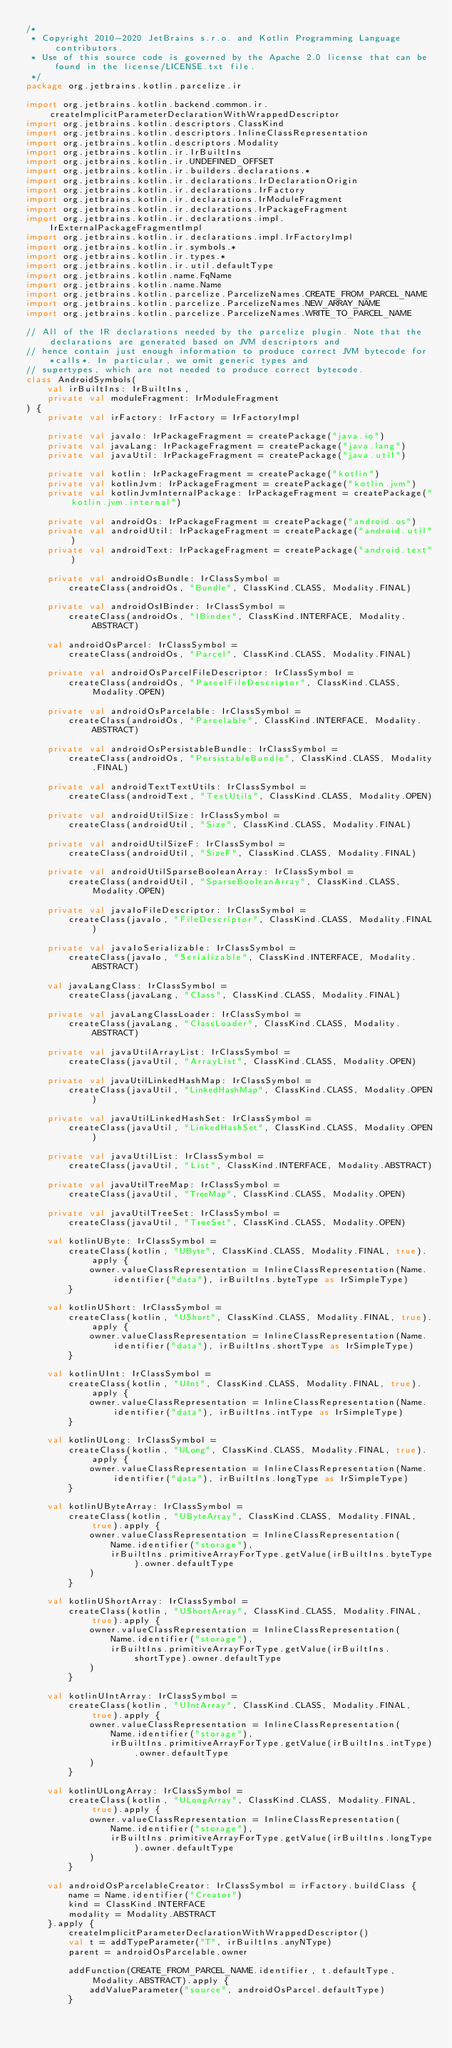<code> <loc_0><loc_0><loc_500><loc_500><_Kotlin_>/*
 * Copyright 2010-2020 JetBrains s.r.o. and Kotlin Programming Language contributors.
 * Use of this source code is governed by the Apache 2.0 license that can be found in the license/LICENSE.txt file.
 */
package org.jetbrains.kotlin.parcelize.ir

import org.jetbrains.kotlin.backend.common.ir.createImplicitParameterDeclarationWithWrappedDescriptor
import org.jetbrains.kotlin.descriptors.ClassKind
import org.jetbrains.kotlin.descriptors.InlineClassRepresentation
import org.jetbrains.kotlin.descriptors.Modality
import org.jetbrains.kotlin.ir.IrBuiltIns
import org.jetbrains.kotlin.ir.UNDEFINED_OFFSET
import org.jetbrains.kotlin.ir.builders.declarations.*
import org.jetbrains.kotlin.ir.declarations.IrDeclarationOrigin
import org.jetbrains.kotlin.ir.declarations.IrFactory
import org.jetbrains.kotlin.ir.declarations.IrModuleFragment
import org.jetbrains.kotlin.ir.declarations.IrPackageFragment
import org.jetbrains.kotlin.ir.declarations.impl.IrExternalPackageFragmentImpl
import org.jetbrains.kotlin.ir.declarations.impl.IrFactoryImpl
import org.jetbrains.kotlin.ir.symbols.*
import org.jetbrains.kotlin.ir.types.*
import org.jetbrains.kotlin.ir.util.defaultType
import org.jetbrains.kotlin.name.FqName
import org.jetbrains.kotlin.name.Name
import org.jetbrains.kotlin.parcelize.ParcelizeNames.CREATE_FROM_PARCEL_NAME
import org.jetbrains.kotlin.parcelize.ParcelizeNames.NEW_ARRAY_NAME
import org.jetbrains.kotlin.parcelize.ParcelizeNames.WRITE_TO_PARCEL_NAME

// All of the IR declarations needed by the parcelize plugin. Note that the declarations are generated based on JVM descriptors and
// hence contain just enough information to produce correct JVM bytecode for *calls*. In particular, we omit generic types and
// supertypes, which are not needed to produce correct bytecode.
class AndroidSymbols(
    val irBuiltIns: IrBuiltIns,
    private val moduleFragment: IrModuleFragment
) {
    private val irFactory: IrFactory = IrFactoryImpl

    private val javaIo: IrPackageFragment = createPackage("java.io")
    private val javaLang: IrPackageFragment = createPackage("java.lang")
    private val javaUtil: IrPackageFragment = createPackage("java.util")

    private val kotlin: IrPackageFragment = createPackage("kotlin")
    private val kotlinJvm: IrPackageFragment = createPackage("kotlin.jvm")
    private val kotlinJvmInternalPackage: IrPackageFragment = createPackage("kotlin.jvm.internal")

    private val androidOs: IrPackageFragment = createPackage("android.os")
    private val androidUtil: IrPackageFragment = createPackage("android.util")
    private val androidText: IrPackageFragment = createPackage("android.text")

    private val androidOsBundle: IrClassSymbol =
        createClass(androidOs, "Bundle", ClassKind.CLASS, Modality.FINAL)

    private val androidOsIBinder: IrClassSymbol =
        createClass(androidOs, "IBinder", ClassKind.INTERFACE, Modality.ABSTRACT)

    val androidOsParcel: IrClassSymbol =
        createClass(androidOs, "Parcel", ClassKind.CLASS, Modality.FINAL)

    private val androidOsParcelFileDescriptor: IrClassSymbol =
        createClass(androidOs, "ParcelFileDescriptor", ClassKind.CLASS, Modality.OPEN)

    private val androidOsParcelable: IrClassSymbol =
        createClass(androidOs, "Parcelable", ClassKind.INTERFACE, Modality.ABSTRACT)

    private val androidOsPersistableBundle: IrClassSymbol =
        createClass(androidOs, "PersistableBundle", ClassKind.CLASS, Modality.FINAL)

    private val androidTextTextUtils: IrClassSymbol =
        createClass(androidText, "TextUtils", ClassKind.CLASS, Modality.OPEN)

    private val androidUtilSize: IrClassSymbol =
        createClass(androidUtil, "Size", ClassKind.CLASS, Modality.FINAL)

    private val androidUtilSizeF: IrClassSymbol =
        createClass(androidUtil, "SizeF", ClassKind.CLASS, Modality.FINAL)

    private val androidUtilSparseBooleanArray: IrClassSymbol =
        createClass(androidUtil, "SparseBooleanArray", ClassKind.CLASS, Modality.OPEN)

    private val javaIoFileDescriptor: IrClassSymbol =
        createClass(javaIo, "FileDescriptor", ClassKind.CLASS, Modality.FINAL)

    private val javaIoSerializable: IrClassSymbol =
        createClass(javaIo, "Serializable", ClassKind.INTERFACE, Modality.ABSTRACT)

    val javaLangClass: IrClassSymbol =
        createClass(javaLang, "Class", ClassKind.CLASS, Modality.FINAL)

    private val javaLangClassLoader: IrClassSymbol =
        createClass(javaLang, "ClassLoader", ClassKind.CLASS, Modality.ABSTRACT)

    private val javaUtilArrayList: IrClassSymbol =
        createClass(javaUtil, "ArrayList", ClassKind.CLASS, Modality.OPEN)

    private val javaUtilLinkedHashMap: IrClassSymbol =
        createClass(javaUtil, "LinkedHashMap", ClassKind.CLASS, Modality.OPEN)

    private val javaUtilLinkedHashSet: IrClassSymbol =
        createClass(javaUtil, "LinkedHashSet", ClassKind.CLASS, Modality.OPEN)

    private val javaUtilList: IrClassSymbol =
        createClass(javaUtil, "List", ClassKind.INTERFACE, Modality.ABSTRACT)

    private val javaUtilTreeMap: IrClassSymbol =
        createClass(javaUtil, "TreeMap", ClassKind.CLASS, Modality.OPEN)

    private val javaUtilTreeSet: IrClassSymbol =
        createClass(javaUtil, "TreeSet", ClassKind.CLASS, Modality.OPEN)

    val kotlinUByte: IrClassSymbol =
        createClass(kotlin, "UByte", ClassKind.CLASS, Modality.FINAL, true).apply {
            owner.valueClassRepresentation = InlineClassRepresentation(Name.identifier("data"), irBuiltIns.byteType as IrSimpleType)
        }

    val kotlinUShort: IrClassSymbol =
        createClass(kotlin, "UShort", ClassKind.CLASS, Modality.FINAL, true).apply {
            owner.valueClassRepresentation = InlineClassRepresentation(Name.identifier("data"), irBuiltIns.shortType as IrSimpleType)
        }

    val kotlinUInt: IrClassSymbol =
        createClass(kotlin, "UInt", ClassKind.CLASS, Modality.FINAL, true).apply {
            owner.valueClassRepresentation = InlineClassRepresentation(Name.identifier("data"), irBuiltIns.intType as IrSimpleType)
        }

    val kotlinULong: IrClassSymbol =
        createClass(kotlin, "ULong", ClassKind.CLASS, Modality.FINAL, true).apply {
            owner.valueClassRepresentation = InlineClassRepresentation(Name.identifier("data"), irBuiltIns.longType as IrSimpleType)
        }

    val kotlinUByteArray: IrClassSymbol =
        createClass(kotlin, "UByteArray", ClassKind.CLASS, Modality.FINAL, true).apply {
            owner.valueClassRepresentation = InlineClassRepresentation(
                Name.identifier("storage"),
                irBuiltIns.primitiveArrayForType.getValue(irBuiltIns.byteType).owner.defaultType
            )
        }

    val kotlinUShortArray: IrClassSymbol =
        createClass(kotlin, "UShortArray", ClassKind.CLASS, Modality.FINAL, true).apply {
            owner.valueClassRepresentation = InlineClassRepresentation(
                Name.identifier("storage"),
                irBuiltIns.primitiveArrayForType.getValue(irBuiltIns.shortType).owner.defaultType
            )
        }

    val kotlinUIntArray: IrClassSymbol =
        createClass(kotlin, "UIntArray", ClassKind.CLASS, Modality.FINAL, true).apply {
            owner.valueClassRepresentation = InlineClassRepresentation(
                Name.identifier("storage"),
                irBuiltIns.primitiveArrayForType.getValue(irBuiltIns.intType).owner.defaultType
            )
        }

    val kotlinULongArray: IrClassSymbol =
        createClass(kotlin, "ULongArray", ClassKind.CLASS, Modality.FINAL, true).apply {
            owner.valueClassRepresentation = InlineClassRepresentation(
                Name.identifier("storage"),
                irBuiltIns.primitiveArrayForType.getValue(irBuiltIns.longType).owner.defaultType
            )
        }

    val androidOsParcelableCreator: IrClassSymbol = irFactory.buildClass {
        name = Name.identifier("Creator")
        kind = ClassKind.INTERFACE
        modality = Modality.ABSTRACT
    }.apply {
        createImplicitParameterDeclarationWithWrappedDescriptor()
        val t = addTypeParameter("T", irBuiltIns.anyNType)
        parent = androidOsParcelable.owner

        addFunction(CREATE_FROM_PARCEL_NAME.identifier, t.defaultType, Modality.ABSTRACT).apply {
            addValueParameter("source", androidOsParcel.defaultType)
        }
</code> 